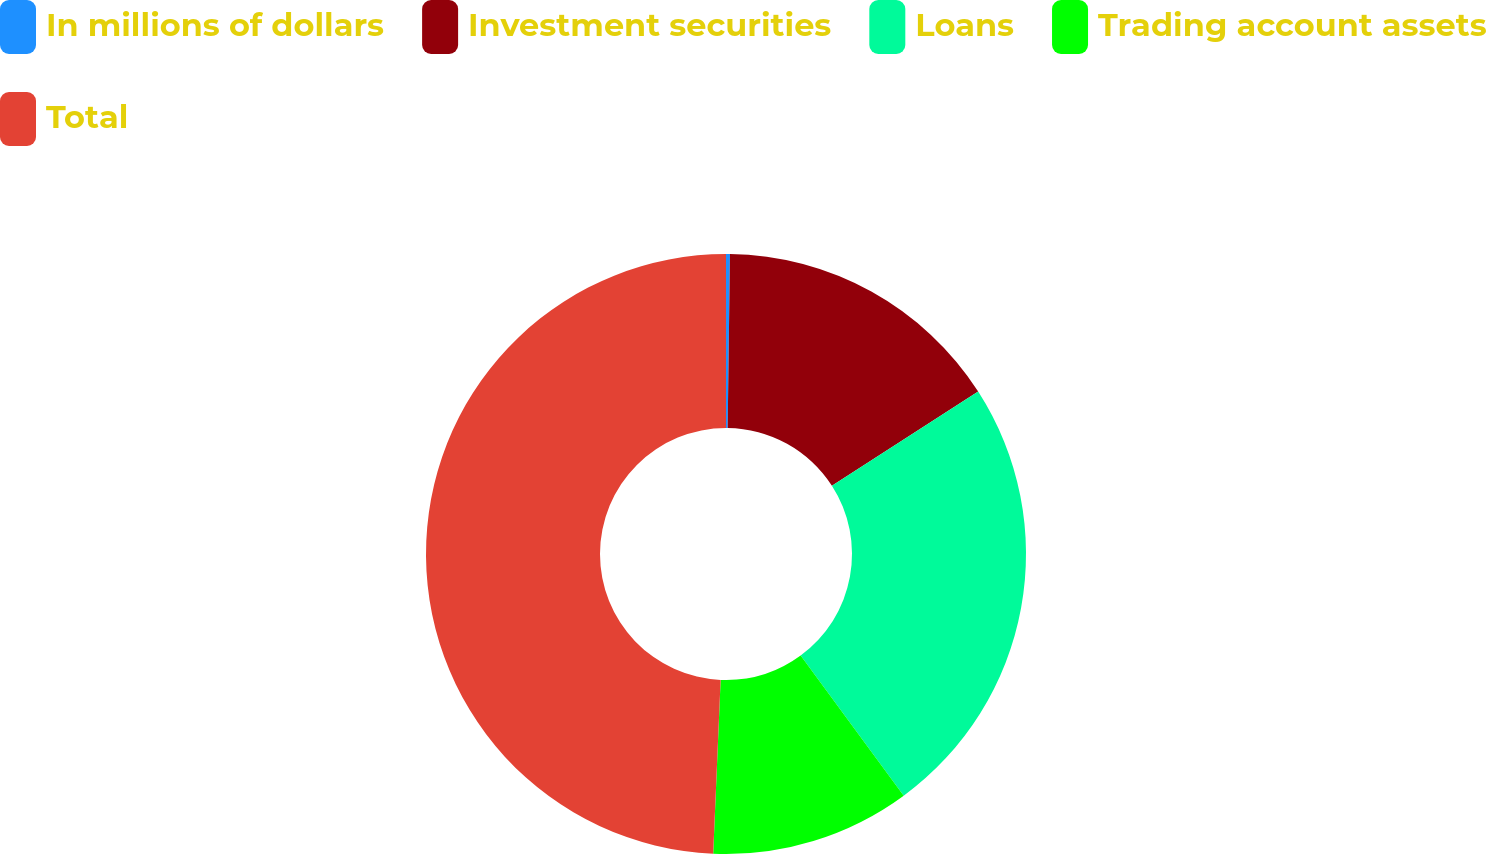Convert chart to OTSL. <chart><loc_0><loc_0><loc_500><loc_500><pie_chart><fcel>In millions of dollars<fcel>Investment securities<fcel>Loans<fcel>Trading account assets<fcel>Total<nl><fcel>0.21%<fcel>15.68%<fcel>24.02%<fcel>10.77%<fcel>49.32%<nl></chart> 